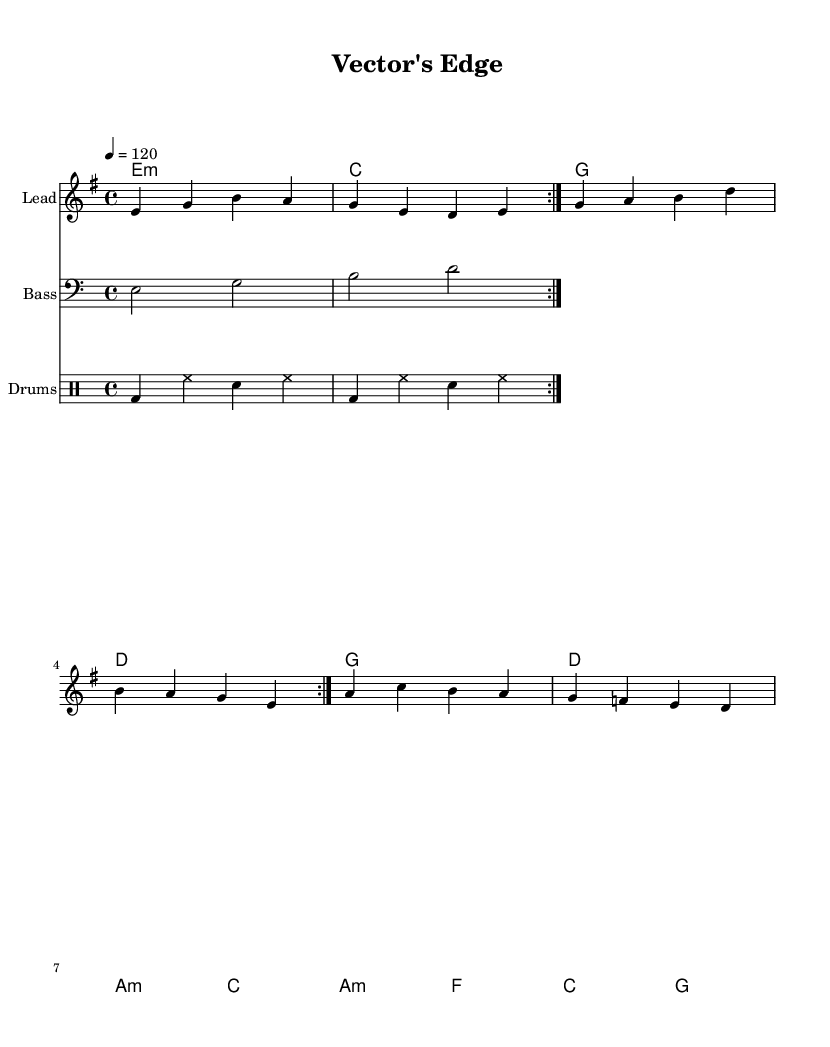What is the key signature of this music? The key signature is E minor, which has one sharp (F#). The music is indicated as E minor above the staff and also includes a consistent use of F# throughout.
Answer: E minor What is the time signature of the piece? The time signature is 4/4, as indicated at the beginning of the score with the '4/4' notation. This means there are four beats in each measure and the quarter note gets one beat.
Answer: 4/4 What is the tempo marking for this composition? The tempo is marked at 120 beats per minute, indicated as '4 = 120' at the beginning of the score. This specifies how fast the piece should be played.
Answer: 120 How many measures are there in the melody? The melody consists of 8 measures, easily counted by the repeated sections and the number of rhythmic groupings shown in the sheet music.
Answer: 8 In which section do the lyrics mention "West Nile"? The lyrics that mention "West Nile" appear in the verse section. Specifically, it's located under the melody notes where the word "West" aligns with the note being played.
Answer: verse What is the primary theme reflected in the chorus? The primary theme in the chorus is centered around disease prevention, as indicated by the lyrics "On the vector's edge we stand, Prevention is our battle plan." This suggests a focus on awareness and response against disease vectors.
Answer: disease prevention 